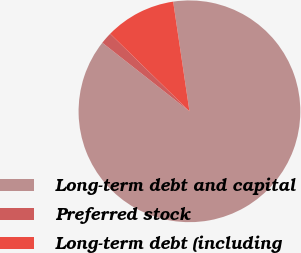Convert chart. <chart><loc_0><loc_0><loc_500><loc_500><pie_chart><fcel>Long-term debt and capital<fcel>Preferred stock<fcel>Long-term debt (including<nl><fcel>87.96%<fcel>1.71%<fcel>10.33%<nl></chart> 